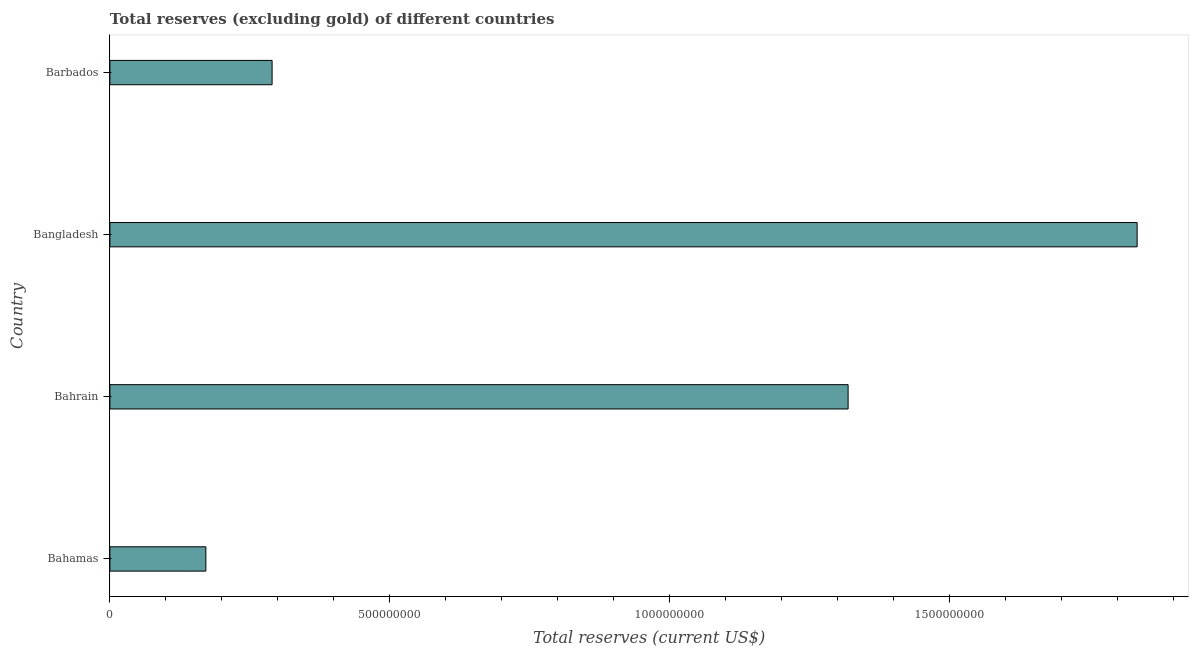Does the graph contain any zero values?
Give a very brief answer. No. Does the graph contain grids?
Give a very brief answer. No. What is the title of the graph?
Your answer should be very brief. Total reserves (excluding gold) of different countries. What is the label or title of the X-axis?
Offer a very short reply. Total reserves (current US$). What is the label or title of the Y-axis?
Offer a terse response. Country. What is the total reserves (excluding gold) in Bahamas?
Your answer should be compact. 1.71e+08. Across all countries, what is the maximum total reserves (excluding gold)?
Offer a terse response. 1.83e+09. Across all countries, what is the minimum total reserves (excluding gold)?
Offer a terse response. 1.71e+08. In which country was the total reserves (excluding gold) minimum?
Your answer should be very brief. Bahamas. What is the sum of the total reserves (excluding gold)?
Your response must be concise. 3.61e+09. What is the difference between the total reserves (excluding gold) in Bahrain and Bangladesh?
Make the answer very short. -5.16e+08. What is the average total reserves (excluding gold) per country?
Provide a short and direct response. 9.04e+08. What is the median total reserves (excluding gold)?
Give a very brief answer. 8.04e+08. In how many countries, is the total reserves (excluding gold) greater than 100000000 US$?
Ensure brevity in your answer.  4. What is the ratio of the total reserves (excluding gold) in Bangladesh to that in Barbados?
Your answer should be compact. 6.33. Is the total reserves (excluding gold) in Bahamas less than that in Bangladesh?
Your answer should be compact. Yes. Is the difference between the total reserves (excluding gold) in Bahrain and Bangladesh greater than the difference between any two countries?
Your response must be concise. No. What is the difference between the highest and the second highest total reserves (excluding gold)?
Your response must be concise. 5.16e+08. Is the sum of the total reserves (excluding gold) in Bahamas and Barbados greater than the maximum total reserves (excluding gold) across all countries?
Ensure brevity in your answer.  No. What is the difference between the highest and the lowest total reserves (excluding gold)?
Your answer should be very brief. 1.66e+09. In how many countries, is the total reserves (excluding gold) greater than the average total reserves (excluding gold) taken over all countries?
Give a very brief answer. 2. How many bars are there?
Keep it short and to the point. 4. Are all the bars in the graph horizontal?
Provide a succinct answer. Yes. How many countries are there in the graph?
Offer a very short reply. 4. What is the difference between two consecutive major ticks on the X-axis?
Give a very brief answer. 5.00e+08. Are the values on the major ticks of X-axis written in scientific E-notation?
Ensure brevity in your answer.  No. What is the Total reserves (current US$) of Bahamas?
Ensure brevity in your answer.  1.71e+08. What is the Total reserves (current US$) in Bahrain?
Ensure brevity in your answer.  1.32e+09. What is the Total reserves (current US$) in Bangladesh?
Provide a succinct answer. 1.83e+09. What is the Total reserves (current US$) in Barbados?
Ensure brevity in your answer.  2.90e+08. What is the difference between the Total reserves (current US$) in Bahamas and Bahrain?
Your response must be concise. -1.15e+09. What is the difference between the Total reserves (current US$) in Bahamas and Bangladesh?
Your answer should be compact. -1.66e+09. What is the difference between the Total reserves (current US$) in Bahamas and Barbados?
Make the answer very short. -1.18e+08. What is the difference between the Total reserves (current US$) in Bahrain and Bangladesh?
Offer a terse response. -5.16e+08. What is the difference between the Total reserves (current US$) in Bahrain and Barbados?
Offer a very short reply. 1.03e+09. What is the difference between the Total reserves (current US$) in Bangladesh and Barbados?
Your answer should be very brief. 1.54e+09. What is the ratio of the Total reserves (current US$) in Bahamas to that in Bahrain?
Your answer should be very brief. 0.13. What is the ratio of the Total reserves (current US$) in Bahamas to that in Bangladesh?
Your answer should be very brief. 0.09. What is the ratio of the Total reserves (current US$) in Bahamas to that in Barbados?
Offer a very short reply. 0.59. What is the ratio of the Total reserves (current US$) in Bahrain to that in Bangladesh?
Your answer should be compact. 0.72. What is the ratio of the Total reserves (current US$) in Bahrain to that in Barbados?
Your answer should be very brief. 4.55. What is the ratio of the Total reserves (current US$) in Bangladesh to that in Barbados?
Your answer should be very brief. 6.33. 